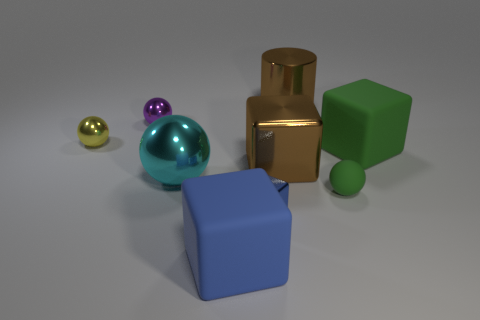What is the material of the object in front of the blue cube that is to the right of the large rubber block that is on the left side of the tiny rubber thing?
Give a very brief answer. Rubber. The shiny object that is the same color as the metal cylinder is what size?
Your response must be concise. Large. What material is the brown block?
Offer a terse response. Metal. Is the material of the large cyan ball the same as the brown thing that is behind the large brown cube?
Provide a succinct answer. Yes. What is the color of the small metallic object in front of the big matte thing that is right of the big blue matte thing?
Make the answer very short. Blue. There is a metallic thing that is in front of the tiny purple shiny object and to the right of the tiny blue metal thing; what is its size?
Keep it short and to the point. Large. What number of other objects are the same shape as the large cyan object?
Provide a short and direct response. 3. Is the shape of the purple object the same as the large matte thing in front of the green sphere?
Keep it short and to the point. No. What number of metallic cubes are to the left of the big green rubber cube?
Your answer should be compact. 2. Is there anything else that has the same material as the large green block?
Keep it short and to the point. Yes. 